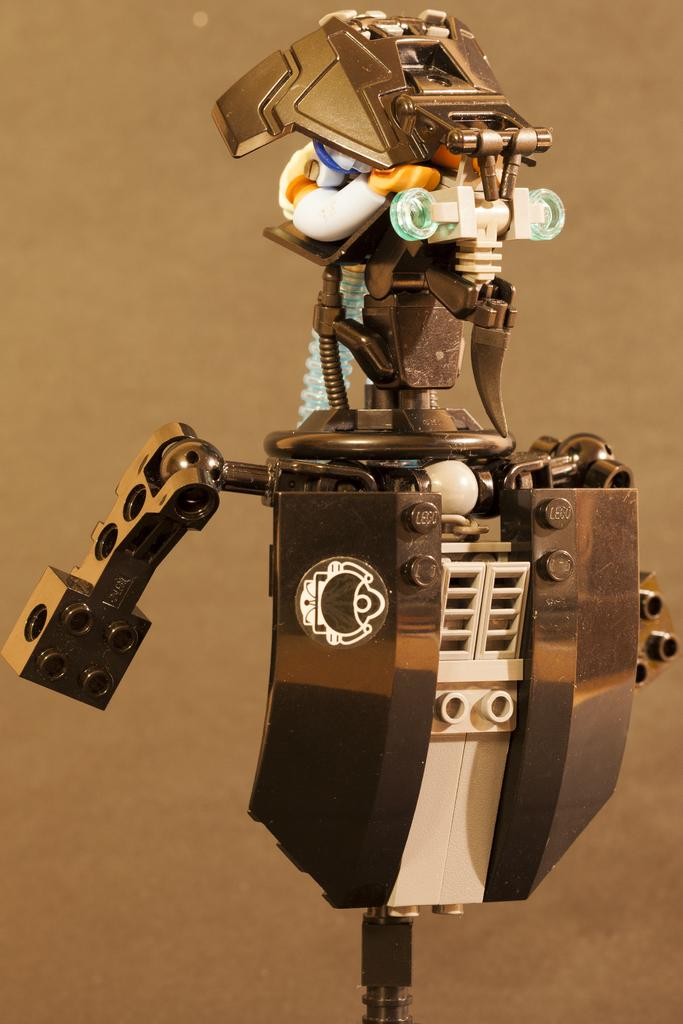What is the main subject of the image? There is a robot in the image. What can be observed about the background of the image? The background of the image is light brownish in color. Can you tell me how many babies are playing chess in the rainstorm in the image? There are no babies or chess games present in the image; it features a robot with a light brownish background. 